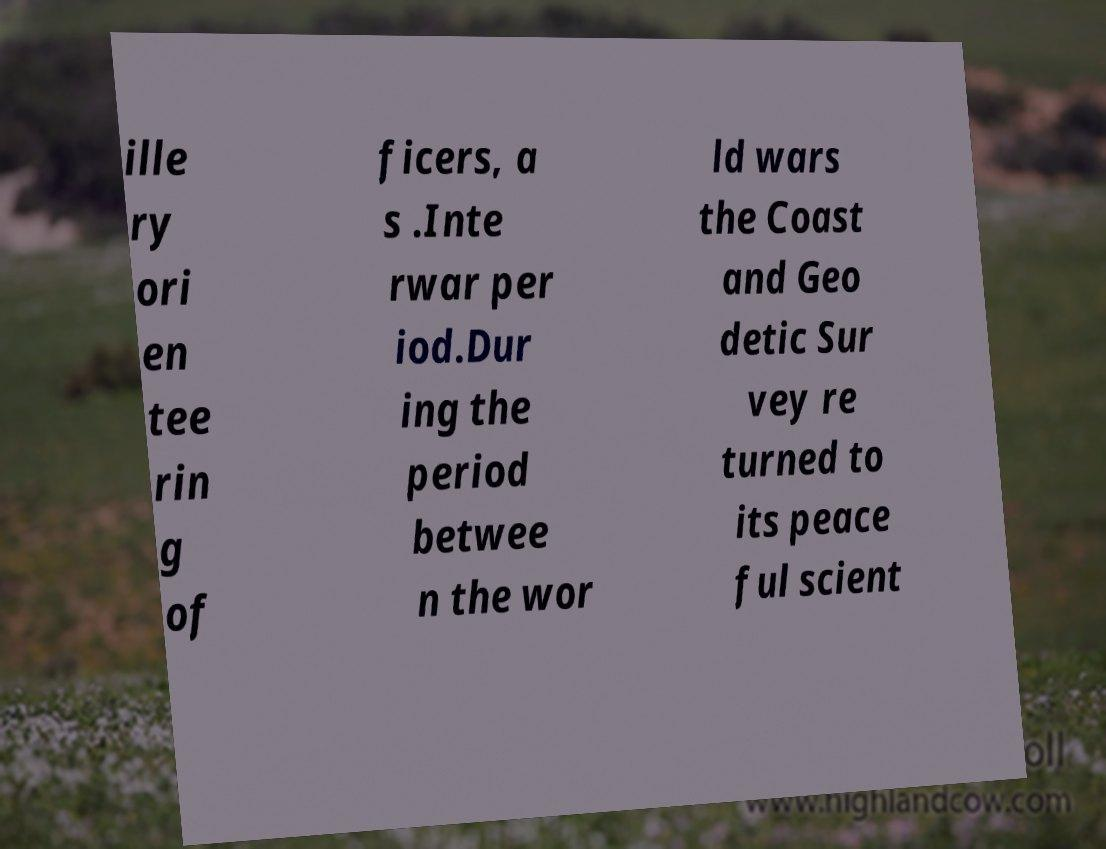Please identify and transcribe the text found in this image. ille ry ori en tee rin g of ficers, a s .Inte rwar per iod.Dur ing the period betwee n the wor ld wars the Coast and Geo detic Sur vey re turned to its peace ful scient 